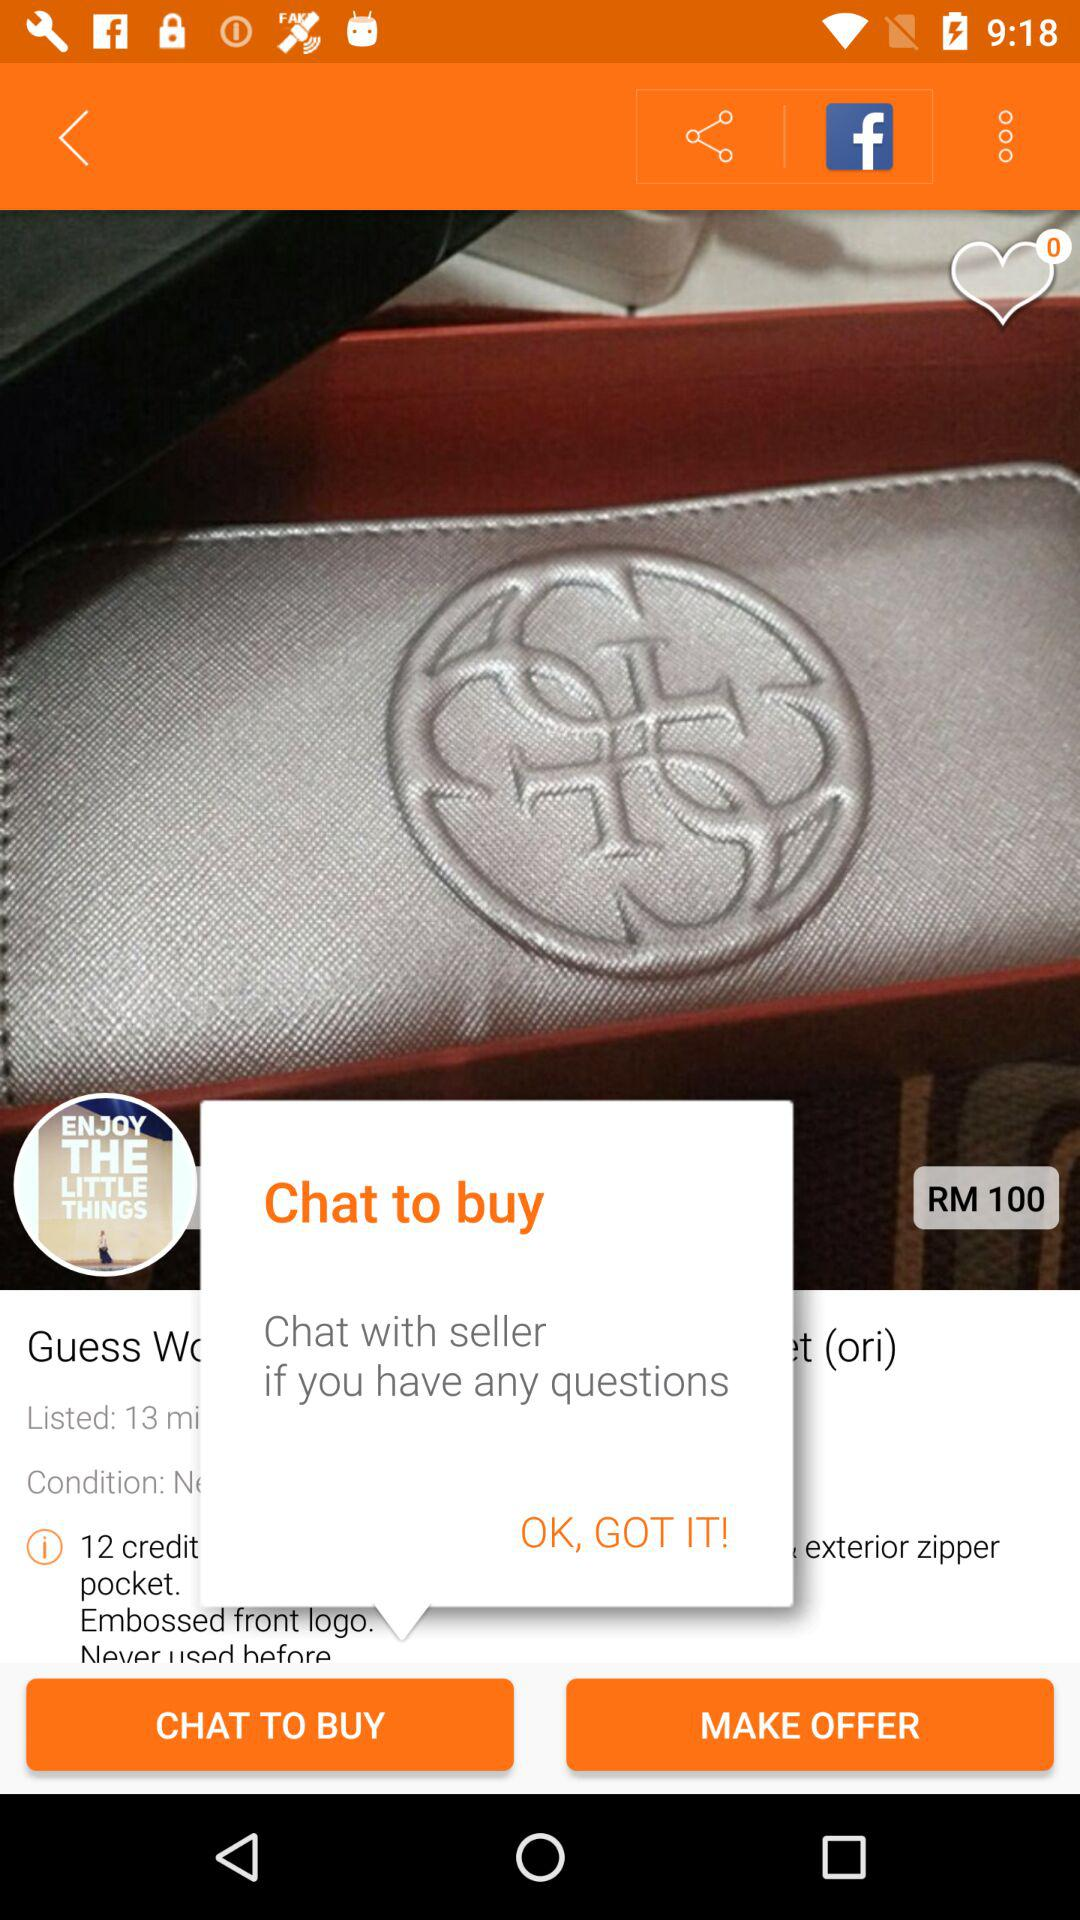What model of the product is shown? The model name is "RM 100". 